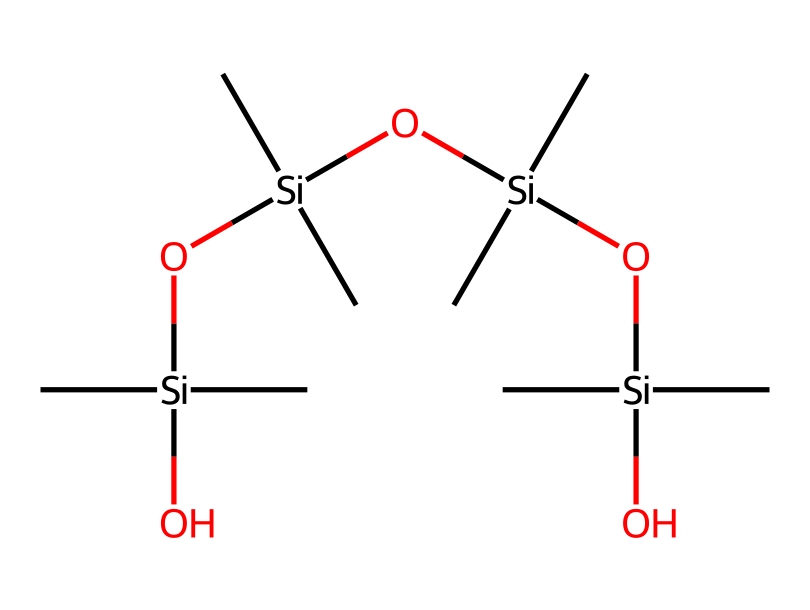What is the main element in this chemical structure? The chemical structure shows silicon atoms as the central atoms, indicated by [Si] in the SMILES notation. This is the primary inorganic element making up the backbone of the polymer.
Answer: silicon How many silicon atoms are present in the structure? By analyzing the SMILES representation, we count four occurrences of the silicon atom symbol [Si], indicating there are four silicon atoms in the polymer chain.
Answer: four What type of functional group is present in this silicone polymer? The presence of the -O- linkages between the silicon atoms, highlighted in the SMILES notation with O[Si], indicates that this structure features siloxane functional groups, which are characteristic of silicone polymers.
Answer: siloxane What is the total number of carbon atoms in this chemical structure? In the SMILES string, every silicon atom is bonded to three carbon atoms (noted as (C)(C)(C)). Since there are four silicon atoms, we multiply: 4 silicon atoms × 3 carbon atoms each = 12 carbon atoms total.
Answer: twelve What is the molecular architecture of this polymer? The structure is a linear or chain-like architecture due to the repeating units of [Si](C)(C)O, creating a continuous sequence of silicon and oxygen that defines its polymeric nature.
Answer: linear How many oxygen atoms are in this chemical structure? Analyzing the SMILES representation, we can observe four instances of the oxygen atom symbol O, which are positioned between the silicon atoms as part of the siloxane linkages.
Answer: four What does the presence of multiple repeating units suggest about the material? The repeating structure of the polymer indicates a high degree of flexibility and stability, allowing it to be effectively used in prosthetic makeup materials where durability and adaptability are required.
Answer: durability 